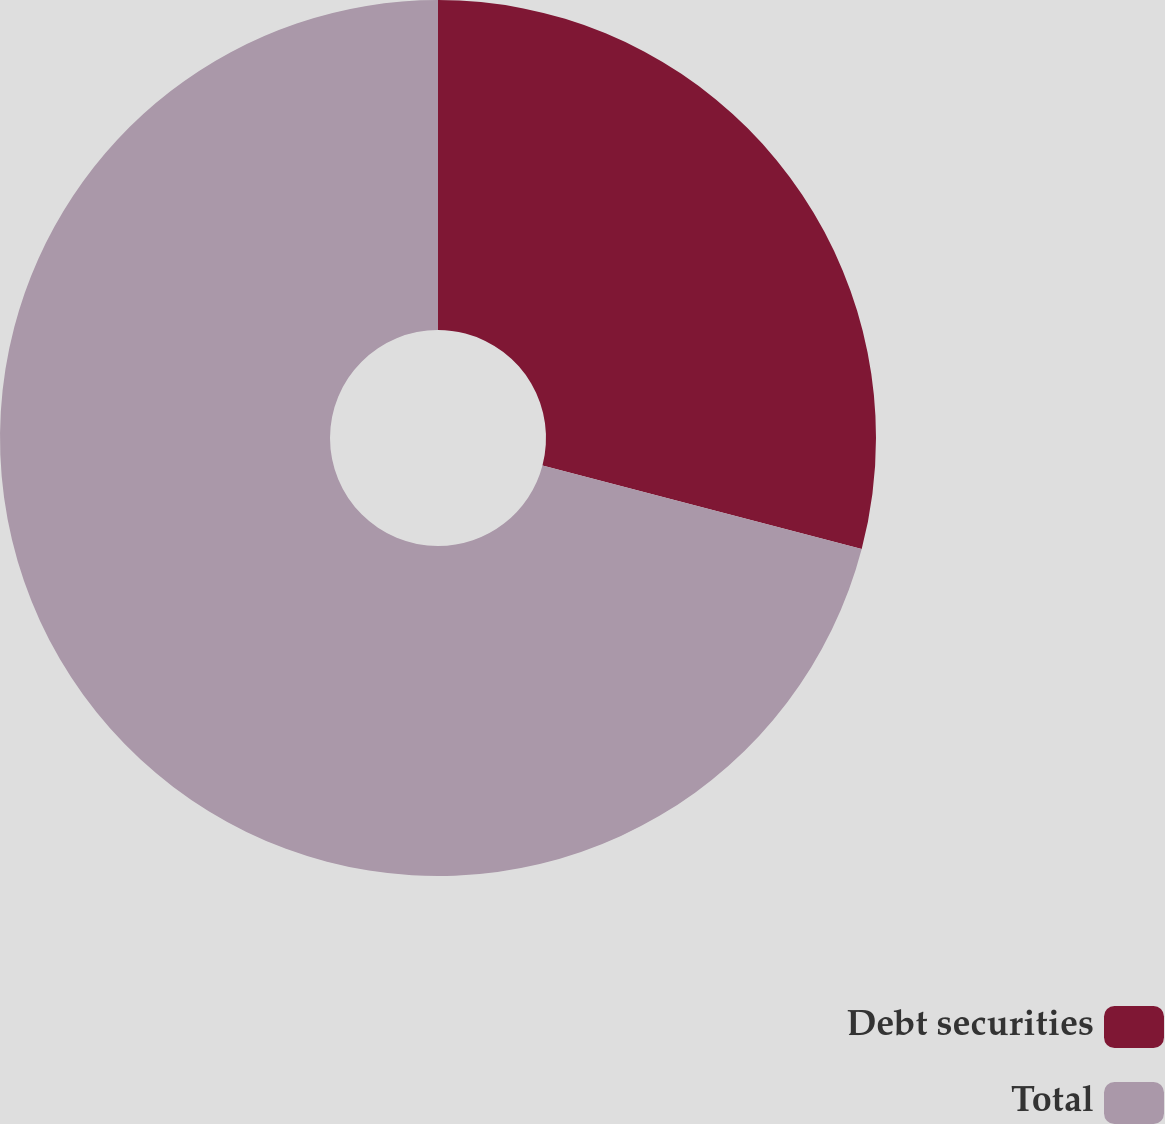<chart> <loc_0><loc_0><loc_500><loc_500><pie_chart><fcel>Debt securities<fcel>Total<nl><fcel>29.08%<fcel>70.92%<nl></chart> 